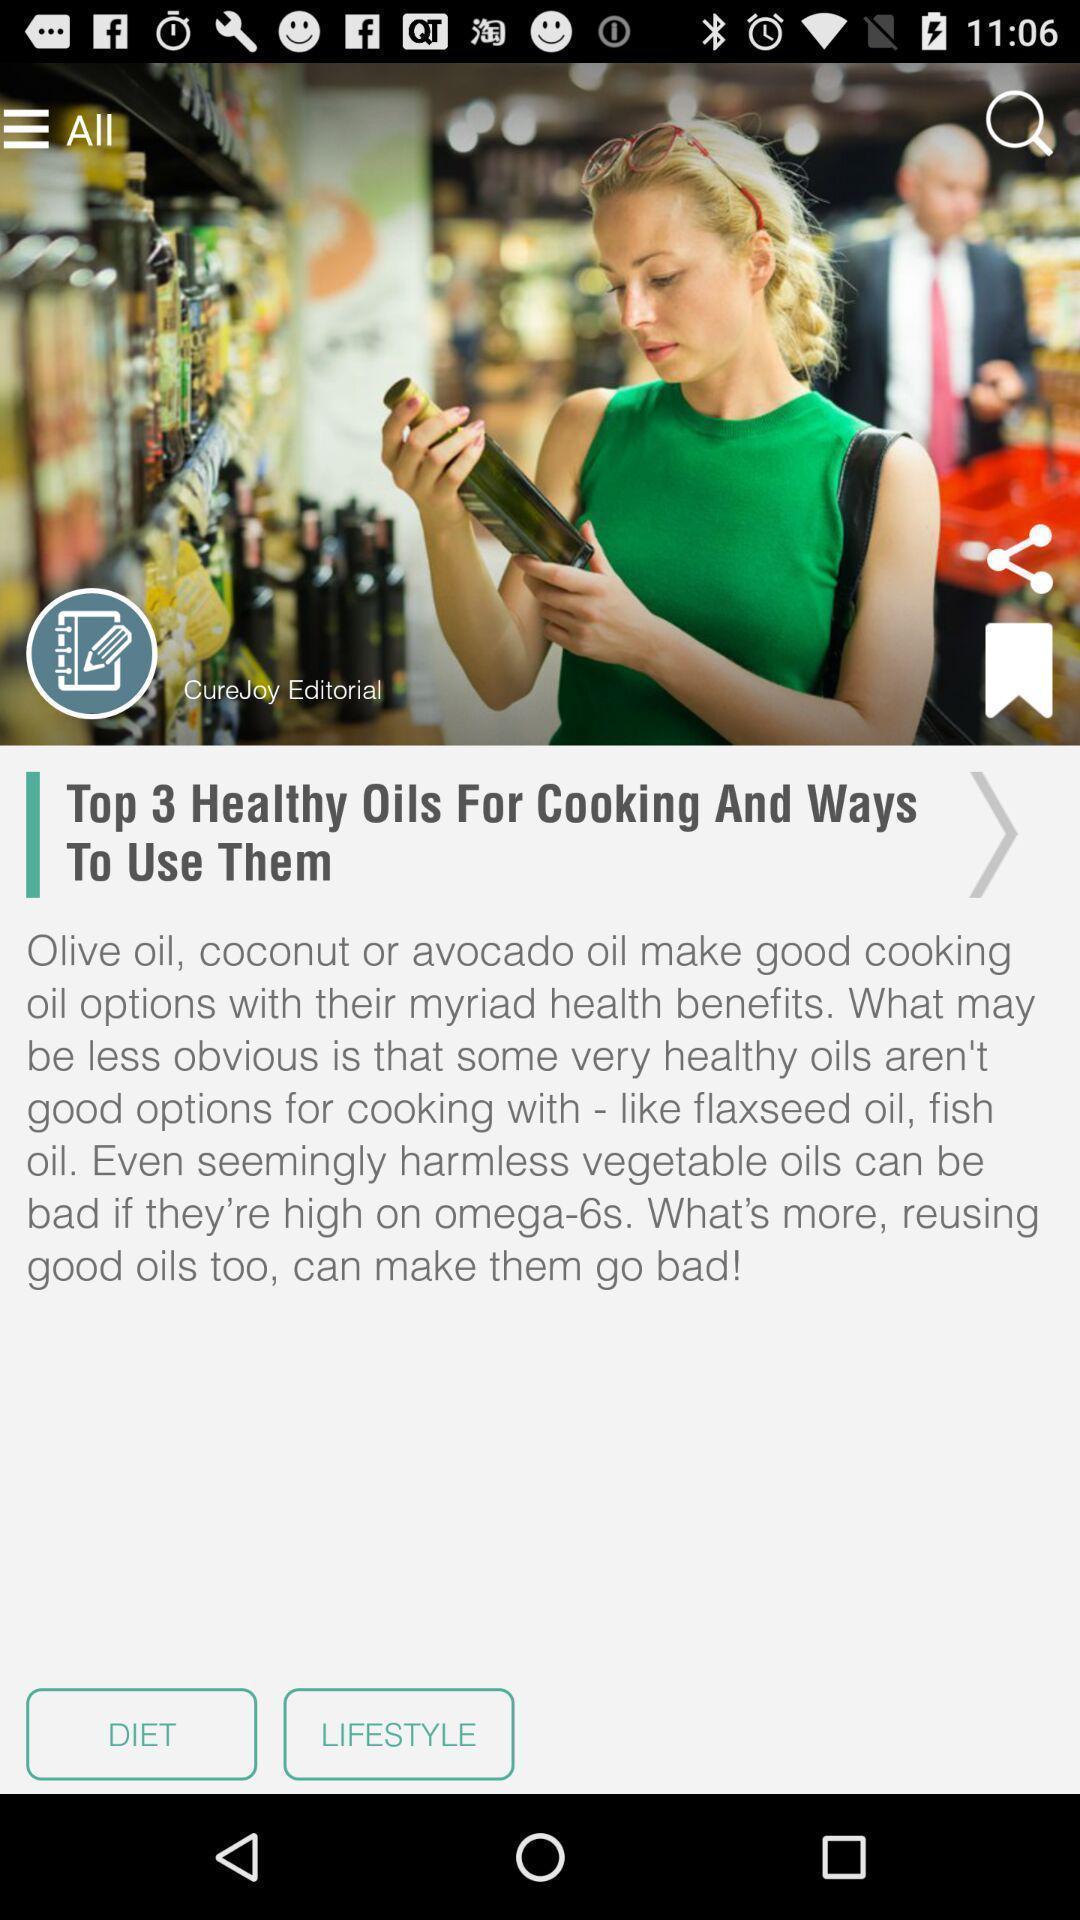Summarize the main components in this picture. Screen displaying an article about healthy oils. 